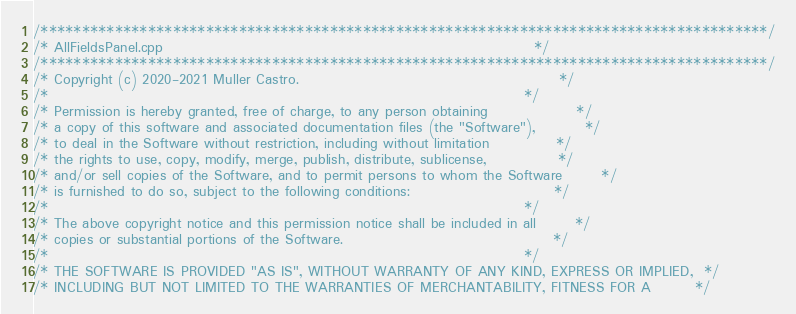<code> <loc_0><loc_0><loc_500><loc_500><_C++_>/****************************************************************************************/
/* AllFieldsPanel.cpp                                                                   */
/****************************************************************************************/
/* Copyright (c) 2020-2021 Muller Castro.                                               */
/*                                                                                      */
/* Permission is hereby granted, free of charge, to any person obtaining                */
/* a copy of this software and associated documentation files (the "Software"),         */
/* to deal in the Software without restriction, including without limitation            */
/* the rights to use, copy, modify, merge, publish, distribute, sublicense,             */
/* and/or sell copies of the Software, and to permit persons to whom the Software       */
/* is furnished to do so, subject to the following conditions:                          */
/*                                                                                      */
/* The above copyright notice and this permission notice shall be included in all       */
/* copies or substantial portions of the Software.                                      */
/*                                                                                      */
/* THE SOFTWARE IS PROVIDED "AS IS", WITHOUT WARRANTY OF ANY KIND, EXPRESS OR IMPLIED,  */
/* INCLUDING BUT NOT LIMITED TO THE WARRANTIES OF MERCHANTABILITY, FITNESS FOR A        */</code> 